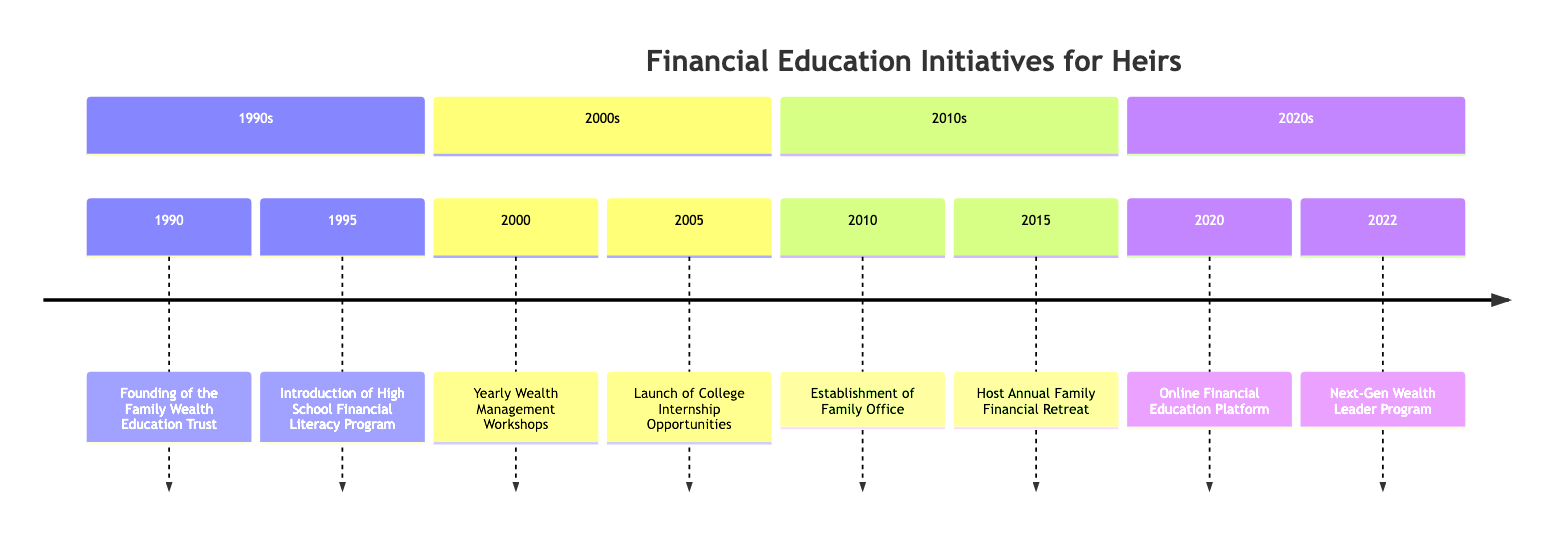What year was the Family Wealth Education Trust founded? The diagram indicates that the Family Wealth Education Trust was founded in 1990. You can find this event listed in the 1990s section of the timeline.
Answer: 1990 Which event occurred in 2005? According to the timeline, the event that occurred in 2005 is the launch of College Internship Opportunities. This is found in the 2000s section of the diagram.
Answer: Launch of College Internship Opportunities How many educational programs are listed in the timeline? To determine the number of educational programs, count the individual events listed on the timeline. There are a total of 8 events from different years.
Answer: 8 What is the focus of the Online Financial Education Platform launched in 2020? The diagram states that the Online Financial Education Platform, launched in 2020, covers courses in investment, budgeting, and financial planning. This information is found in the 2020s section.
Answer: investment, budgeting, financial planning Which organization partnered with the family for the High School Financial Literacy Program? The timeline specifies that the family partnered with Junior Achievement for the High School Financial Literacy Program introduced in 1995. This partnership is clearly stated in the event description.
Answer: Junior Achievement What did the Annual Family Financial Retreat of 2015 focus on? The event description from 2015 mentions that the Annual Family Financial Retreat organized lectures from financial experts discussing topics like asset diversification and tax optimization. This shows the retreat's educational focus.
Answer: asset diversification and tax optimization What significant initiative was taken in 2010? According to the diagram, a significant initiative taken in 2010 was the establishment of a Family Office, aimed at managing family assets and providing personalized financial education. This is listed in the 2010s section.
Answer: Establishment of Family Office Which educational initiative came after the Yearly Wealth Management Workshops? The timeline indicates that after the Yearly Wealth Management Workshops initiated in 2000, the next initiative was the Launch of College Internship Opportunities in 2005. This requires looking at the chronological order of events.
Answer: Launch of College Internship Opportunities 